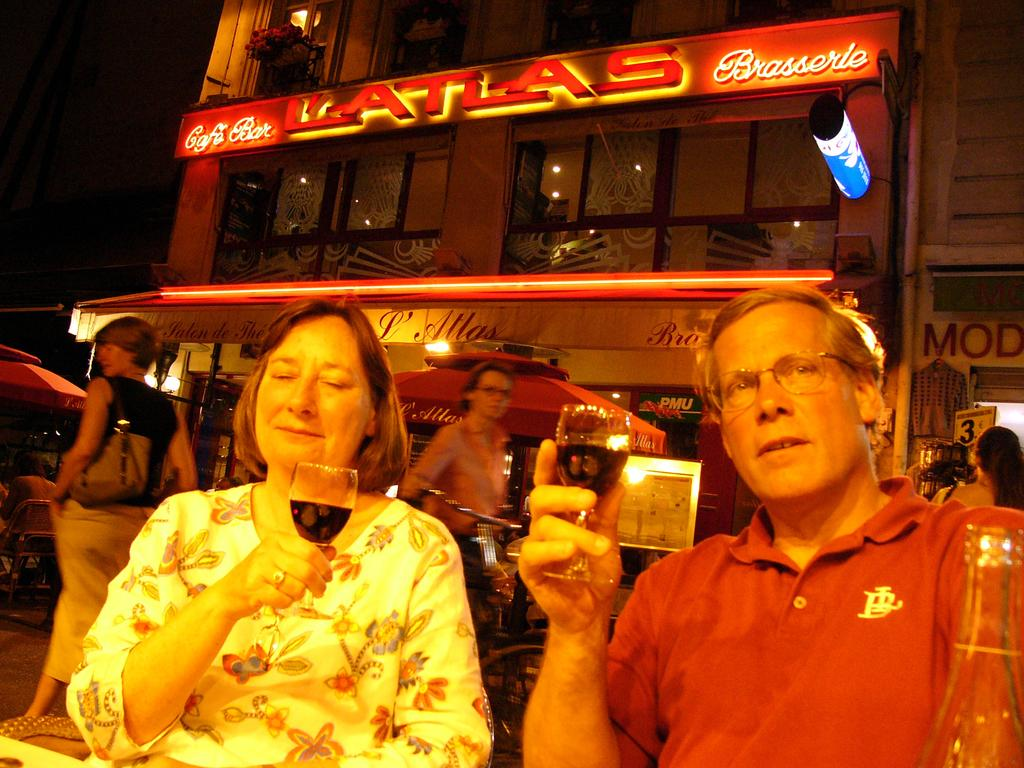How many people are sitting in the image? There are 2 people sitting in the image. What are the people holding in their hands? The people are holding a glass of drink. Can you describe the background of the image? There are other people visible in the background, as well as buildings. Are there any icicles hanging from the buildings in the image? There is no mention of icicles in the provided facts, so we cannot determine if any are present in the image. 